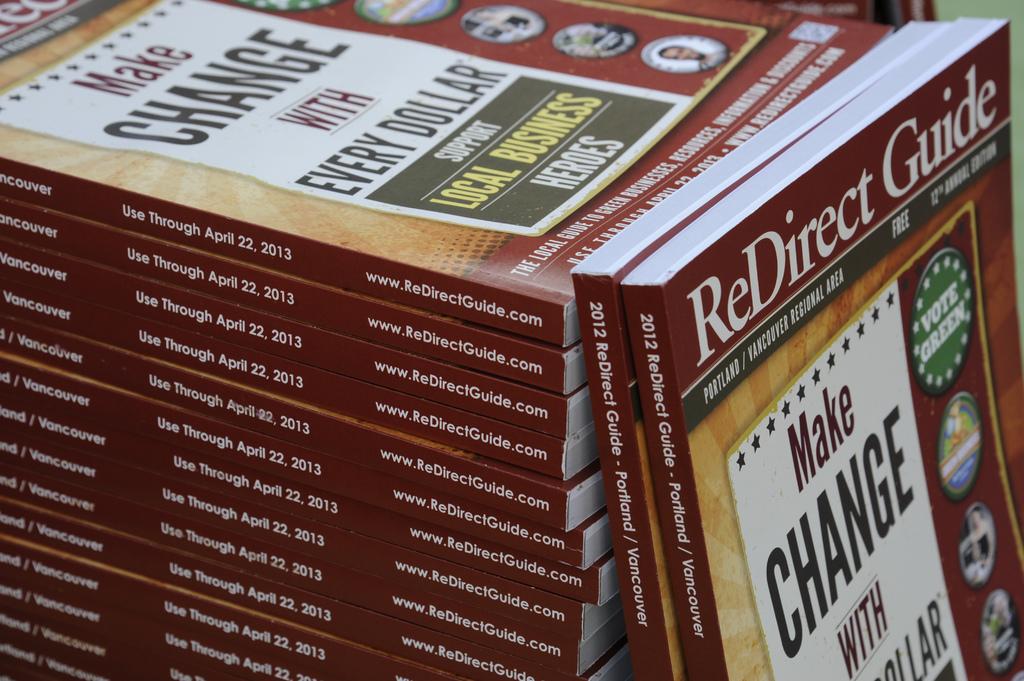What kind of guide is this?
Your response must be concise. Redirect. 